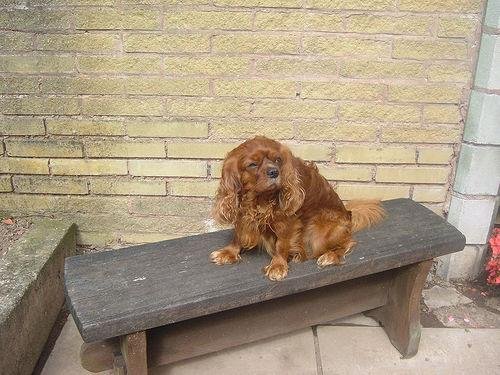Give a concise description of the dog's breed and appearance. A small cocker spaniel dog with brown fur, long shaggy ears, and a black nose. Convey the primary object's interactions with its current surroundings. The dog is sitting on the wooden bench with its paws resting on the bench and observing its surroundings. Mention two distinct features of the dog's face. The dog has a black nose and long floppy ears. What is the primary object's appearance, and how is it positioned? The dog is brown, furry, with long ears and a black nose, sitting on the bench. Identify the primary object and its action in the picture. Small brown dog sitting on a wooden bench. Provide information on the exterior wall of the building. The exterior of the building is beige bricked, worn, and with a white block vertical column. Elaborate on the condition of the ground, plants and sidewalk in the image. There are bright pink flowers on the ground with petals scattered on the sidewalk, which is broken in one area. Provide a brief summary of the setting surrounding the main object. The dog is outside on a bench near a beige brick building with a worn brick wall and a cement planter. Describe the location and appearance of the bench. The grey wooden bench is backless and located outside near the building with black legs. List three noticeable features in the area surrounding the focal point. Yellow wall, black bench legs, bright pink flowers on ground. 